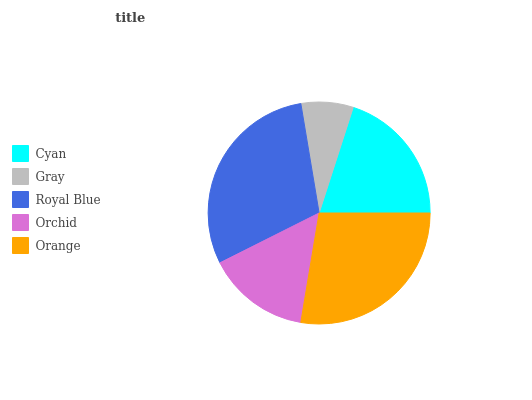Is Gray the minimum?
Answer yes or no. Yes. Is Royal Blue the maximum?
Answer yes or no. Yes. Is Royal Blue the minimum?
Answer yes or no. No. Is Gray the maximum?
Answer yes or no. No. Is Royal Blue greater than Gray?
Answer yes or no. Yes. Is Gray less than Royal Blue?
Answer yes or no. Yes. Is Gray greater than Royal Blue?
Answer yes or no. No. Is Royal Blue less than Gray?
Answer yes or no. No. Is Cyan the high median?
Answer yes or no. Yes. Is Cyan the low median?
Answer yes or no. Yes. Is Gray the high median?
Answer yes or no. No. Is Royal Blue the low median?
Answer yes or no. No. 